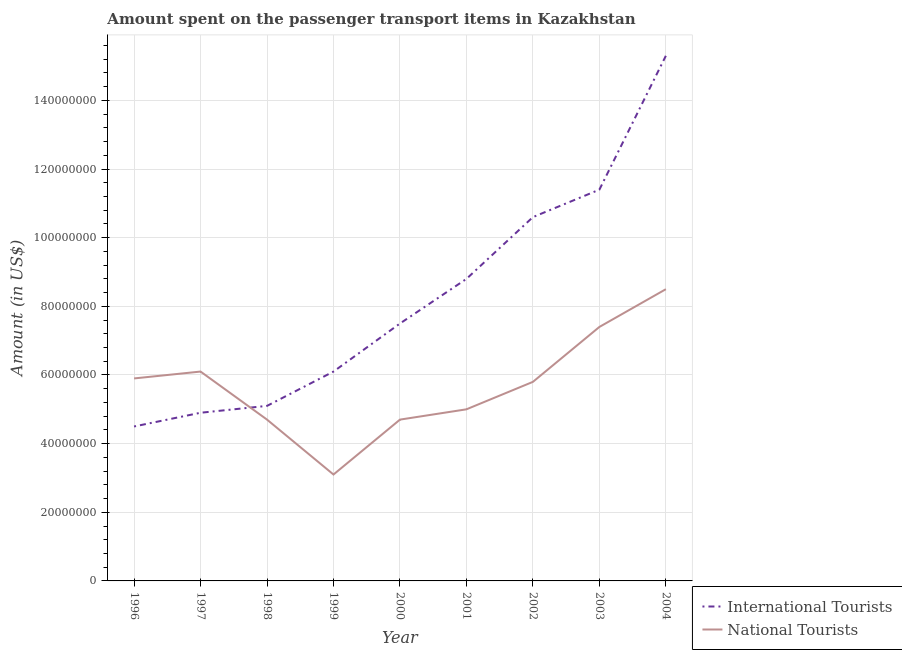Does the line corresponding to amount spent on transport items of international tourists intersect with the line corresponding to amount spent on transport items of national tourists?
Your answer should be compact. Yes. What is the amount spent on transport items of national tourists in 1998?
Keep it short and to the point. 4.70e+07. Across all years, what is the maximum amount spent on transport items of international tourists?
Ensure brevity in your answer.  1.53e+08. Across all years, what is the minimum amount spent on transport items of national tourists?
Ensure brevity in your answer.  3.10e+07. In which year was the amount spent on transport items of national tourists maximum?
Ensure brevity in your answer.  2004. In which year was the amount spent on transport items of national tourists minimum?
Provide a short and direct response. 1999. What is the total amount spent on transport items of international tourists in the graph?
Your answer should be compact. 7.42e+08. What is the difference between the amount spent on transport items of international tourists in 1999 and that in 2004?
Make the answer very short. -9.20e+07. What is the difference between the amount spent on transport items of national tourists in 2003 and the amount spent on transport items of international tourists in 1997?
Provide a short and direct response. 2.50e+07. What is the average amount spent on transport items of national tourists per year?
Make the answer very short. 5.69e+07. In the year 1999, what is the difference between the amount spent on transport items of international tourists and amount spent on transport items of national tourists?
Ensure brevity in your answer.  3.00e+07. In how many years, is the amount spent on transport items of international tourists greater than 144000000 US$?
Give a very brief answer. 1. What is the ratio of the amount spent on transport items of international tourists in 1997 to that in 1998?
Provide a short and direct response. 0.96. Is the amount spent on transport items of international tourists in 1998 less than that in 2003?
Make the answer very short. Yes. What is the difference between the highest and the second highest amount spent on transport items of international tourists?
Provide a short and direct response. 3.90e+07. What is the difference between the highest and the lowest amount spent on transport items of international tourists?
Give a very brief answer. 1.08e+08. In how many years, is the amount spent on transport items of national tourists greater than the average amount spent on transport items of national tourists taken over all years?
Provide a succinct answer. 5. Is the amount spent on transport items of national tourists strictly greater than the amount spent on transport items of international tourists over the years?
Provide a short and direct response. No. How many lines are there?
Ensure brevity in your answer.  2. How many years are there in the graph?
Give a very brief answer. 9. Does the graph contain any zero values?
Ensure brevity in your answer.  No. Does the graph contain grids?
Your answer should be very brief. Yes. How are the legend labels stacked?
Your answer should be compact. Vertical. What is the title of the graph?
Provide a short and direct response. Amount spent on the passenger transport items in Kazakhstan. Does "Investment" appear as one of the legend labels in the graph?
Offer a terse response. No. What is the label or title of the X-axis?
Give a very brief answer. Year. What is the Amount (in US$) of International Tourists in 1996?
Make the answer very short. 4.50e+07. What is the Amount (in US$) in National Tourists in 1996?
Keep it short and to the point. 5.90e+07. What is the Amount (in US$) of International Tourists in 1997?
Offer a very short reply. 4.90e+07. What is the Amount (in US$) in National Tourists in 1997?
Your answer should be compact. 6.10e+07. What is the Amount (in US$) in International Tourists in 1998?
Offer a very short reply. 5.10e+07. What is the Amount (in US$) in National Tourists in 1998?
Keep it short and to the point. 4.70e+07. What is the Amount (in US$) in International Tourists in 1999?
Your response must be concise. 6.10e+07. What is the Amount (in US$) in National Tourists in 1999?
Offer a very short reply. 3.10e+07. What is the Amount (in US$) in International Tourists in 2000?
Offer a terse response. 7.50e+07. What is the Amount (in US$) in National Tourists in 2000?
Provide a short and direct response. 4.70e+07. What is the Amount (in US$) in International Tourists in 2001?
Ensure brevity in your answer.  8.80e+07. What is the Amount (in US$) in National Tourists in 2001?
Keep it short and to the point. 5.00e+07. What is the Amount (in US$) of International Tourists in 2002?
Offer a terse response. 1.06e+08. What is the Amount (in US$) in National Tourists in 2002?
Offer a very short reply. 5.80e+07. What is the Amount (in US$) of International Tourists in 2003?
Give a very brief answer. 1.14e+08. What is the Amount (in US$) in National Tourists in 2003?
Offer a very short reply. 7.40e+07. What is the Amount (in US$) in International Tourists in 2004?
Give a very brief answer. 1.53e+08. What is the Amount (in US$) in National Tourists in 2004?
Provide a succinct answer. 8.50e+07. Across all years, what is the maximum Amount (in US$) in International Tourists?
Your answer should be compact. 1.53e+08. Across all years, what is the maximum Amount (in US$) in National Tourists?
Keep it short and to the point. 8.50e+07. Across all years, what is the minimum Amount (in US$) in International Tourists?
Offer a very short reply. 4.50e+07. Across all years, what is the minimum Amount (in US$) in National Tourists?
Your answer should be very brief. 3.10e+07. What is the total Amount (in US$) in International Tourists in the graph?
Your response must be concise. 7.42e+08. What is the total Amount (in US$) of National Tourists in the graph?
Offer a terse response. 5.12e+08. What is the difference between the Amount (in US$) of International Tourists in 1996 and that in 1998?
Provide a short and direct response. -6.00e+06. What is the difference between the Amount (in US$) of International Tourists in 1996 and that in 1999?
Your answer should be very brief. -1.60e+07. What is the difference between the Amount (in US$) in National Tourists in 1996 and that in 1999?
Make the answer very short. 2.80e+07. What is the difference between the Amount (in US$) in International Tourists in 1996 and that in 2000?
Give a very brief answer. -3.00e+07. What is the difference between the Amount (in US$) in National Tourists in 1996 and that in 2000?
Your answer should be very brief. 1.20e+07. What is the difference between the Amount (in US$) of International Tourists in 1996 and that in 2001?
Ensure brevity in your answer.  -4.30e+07. What is the difference between the Amount (in US$) of National Tourists in 1996 and that in 2001?
Provide a short and direct response. 9.00e+06. What is the difference between the Amount (in US$) of International Tourists in 1996 and that in 2002?
Offer a terse response. -6.10e+07. What is the difference between the Amount (in US$) in National Tourists in 1996 and that in 2002?
Your answer should be compact. 1.00e+06. What is the difference between the Amount (in US$) of International Tourists in 1996 and that in 2003?
Offer a terse response. -6.90e+07. What is the difference between the Amount (in US$) of National Tourists in 1996 and that in 2003?
Your answer should be very brief. -1.50e+07. What is the difference between the Amount (in US$) in International Tourists in 1996 and that in 2004?
Offer a terse response. -1.08e+08. What is the difference between the Amount (in US$) in National Tourists in 1996 and that in 2004?
Your answer should be compact. -2.60e+07. What is the difference between the Amount (in US$) in International Tourists in 1997 and that in 1998?
Your answer should be very brief. -2.00e+06. What is the difference between the Amount (in US$) in National Tourists in 1997 and that in 1998?
Offer a very short reply. 1.40e+07. What is the difference between the Amount (in US$) of International Tourists in 1997 and that in 1999?
Make the answer very short. -1.20e+07. What is the difference between the Amount (in US$) of National Tourists in 1997 and that in 1999?
Make the answer very short. 3.00e+07. What is the difference between the Amount (in US$) of International Tourists in 1997 and that in 2000?
Your answer should be compact. -2.60e+07. What is the difference between the Amount (in US$) in National Tourists in 1997 and that in 2000?
Offer a terse response. 1.40e+07. What is the difference between the Amount (in US$) of International Tourists in 1997 and that in 2001?
Your answer should be compact. -3.90e+07. What is the difference between the Amount (in US$) in National Tourists in 1997 and that in 2001?
Ensure brevity in your answer.  1.10e+07. What is the difference between the Amount (in US$) of International Tourists in 1997 and that in 2002?
Ensure brevity in your answer.  -5.70e+07. What is the difference between the Amount (in US$) in National Tourists in 1997 and that in 2002?
Your answer should be very brief. 3.00e+06. What is the difference between the Amount (in US$) of International Tourists in 1997 and that in 2003?
Offer a terse response. -6.50e+07. What is the difference between the Amount (in US$) in National Tourists in 1997 and that in 2003?
Give a very brief answer. -1.30e+07. What is the difference between the Amount (in US$) of International Tourists in 1997 and that in 2004?
Offer a terse response. -1.04e+08. What is the difference between the Amount (in US$) in National Tourists in 1997 and that in 2004?
Make the answer very short. -2.40e+07. What is the difference between the Amount (in US$) in International Tourists in 1998 and that in 1999?
Your answer should be compact. -1.00e+07. What is the difference between the Amount (in US$) in National Tourists in 1998 and that in 1999?
Provide a succinct answer. 1.60e+07. What is the difference between the Amount (in US$) in International Tourists in 1998 and that in 2000?
Your answer should be compact. -2.40e+07. What is the difference between the Amount (in US$) of International Tourists in 1998 and that in 2001?
Offer a very short reply. -3.70e+07. What is the difference between the Amount (in US$) in International Tourists in 1998 and that in 2002?
Keep it short and to the point. -5.50e+07. What is the difference between the Amount (in US$) in National Tourists in 1998 and that in 2002?
Ensure brevity in your answer.  -1.10e+07. What is the difference between the Amount (in US$) in International Tourists in 1998 and that in 2003?
Offer a terse response. -6.30e+07. What is the difference between the Amount (in US$) in National Tourists in 1998 and that in 2003?
Provide a succinct answer. -2.70e+07. What is the difference between the Amount (in US$) of International Tourists in 1998 and that in 2004?
Offer a terse response. -1.02e+08. What is the difference between the Amount (in US$) in National Tourists in 1998 and that in 2004?
Provide a short and direct response. -3.80e+07. What is the difference between the Amount (in US$) of International Tourists in 1999 and that in 2000?
Give a very brief answer. -1.40e+07. What is the difference between the Amount (in US$) in National Tourists in 1999 and that in 2000?
Keep it short and to the point. -1.60e+07. What is the difference between the Amount (in US$) in International Tourists in 1999 and that in 2001?
Offer a very short reply. -2.70e+07. What is the difference between the Amount (in US$) in National Tourists in 1999 and that in 2001?
Give a very brief answer. -1.90e+07. What is the difference between the Amount (in US$) of International Tourists in 1999 and that in 2002?
Your response must be concise. -4.50e+07. What is the difference between the Amount (in US$) of National Tourists in 1999 and that in 2002?
Your response must be concise. -2.70e+07. What is the difference between the Amount (in US$) of International Tourists in 1999 and that in 2003?
Ensure brevity in your answer.  -5.30e+07. What is the difference between the Amount (in US$) in National Tourists in 1999 and that in 2003?
Ensure brevity in your answer.  -4.30e+07. What is the difference between the Amount (in US$) in International Tourists in 1999 and that in 2004?
Give a very brief answer. -9.20e+07. What is the difference between the Amount (in US$) of National Tourists in 1999 and that in 2004?
Offer a very short reply. -5.40e+07. What is the difference between the Amount (in US$) of International Tourists in 2000 and that in 2001?
Your response must be concise. -1.30e+07. What is the difference between the Amount (in US$) in National Tourists in 2000 and that in 2001?
Your response must be concise. -3.00e+06. What is the difference between the Amount (in US$) of International Tourists in 2000 and that in 2002?
Provide a short and direct response. -3.10e+07. What is the difference between the Amount (in US$) in National Tourists in 2000 and that in 2002?
Your answer should be very brief. -1.10e+07. What is the difference between the Amount (in US$) in International Tourists in 2000 and that in 2003?
Offer a very short reply. -3.90e+07. What is the difference between the Amount (in US$) in National Tourists in 2000 and that in 2003?
Provide a succinct answer. -2.70e+07. What is the difference between the Amount (in US$) of International Tourists in 2000 and that in 2004?
Give a very brief answer. -7.80e+07. What is the difference between the Amount (in US$) in National Tourists in 2000 and that in 2004?
Ensure brevity in your answer.  -3.80e+07. What is the difference between the Amount (in US$) in International Tourists in 2001 and that in 2002?
Your answer should be very brief. -1.80e+07. What is the difference between the Amount (in US$) in National Tourists in 2001 and that in 2002?
Your answer should be very brief. -8.00e+06. What is the difference between the Amount (in US$) in International Tourists in 2001 and that in 2003?
Offer a very short reply. -2.60e+07. What is the difference between the Amount (in US$) of National Tourists in 2001 and that in 2003?
Offer a terse response. -2.40e+07. What is the difference between the Amount (in US$) of International Tourists in 2001 and that in 2004?
Ensure brevity in your answer.  -6.50e+07. What is the difference between the Amount (in US$) in National Tourists in 2001 and that in 2004?
Give a very brief answer. -3.50e+07. What is the difference between the Amount (in US$) of International Tourists in 2002 and that in 2003?
Make the answer very short. -8.00e+06. What is the difference between the Amount (in US$) of National Tourists in 2002 and that in 2003?
Keep it short and to the point. -1.60e+07. What is the difference between the Amount (in US$) in International Tourists in 2002 and that in 2004?
Your response must be concise. -4.70e+07. What is the difference between the Amount (in US$) in National Tourists in 2002 and that in 2004?
Your answer should be compact. -2.70e+07. What is the difference between the Amount (in US$) of International Tourists in 2003 and that in 2004?
Keep it short and to the point. -3.90e+07. What is the difference between the Amount (in US$) in National Tourists in 2003 and that in 2004?
Provide a succinct answer. -1.10e+07. What is the difference between the Amount (in US$) of International Tourists in 1996 and the Amount (in US$) of National Tourists in 1997?
Provide a short and direct response. -1.60e+07. What is the difference between the Amount (in US$) of International Tourists in 1996 and the Amount (in US$) of National Tourists in 1998?
Keep it short and to the point. -2.00e+06. What is the difference between the Amount (in US$) in International Tourists in 1996 and the Amount (in US$) in National Tourists in 1999?
Keep it short and to the point. 1.40e+07. What is the difference between the Amount (in US$) in International Tourists in 1996 and the Amount (in US$) in National Tourists in 2000?
Make the answer very short. -2.00e+06. What is the difference between the Amount (in US$) of International Tourists in 1996 and the Amount (in US$) of National Tourists in 2001?
Provide a short and direct response. -5.00e+06. What is the difference between the Amount (in US$) in International Tourists in 1996 and the Amount (in US$) in National Tourists in 2002?
Give a very brief answer. -1.30e+07. What is the difference between the Amount (in US$) in International Tourists in 1996 and the Amount (in US$) in National Tourists in 2003?
Make the answer very short. -2.90e+07. What is the difference between the Amount (in US$) in International Tourists in 1996 and the Amount (in US$) in National Tourists in 2004?
Your answer should be compact. -4.00e+07. What is the difference between the Amount (in US$) in International Tourists in 1997 and the Amount (in US$) in National Tourists in 1998?
Give a very brief answer. 2.00e+06. What is the difference between the Amount (in US$) in International Tourists in 1997 and the Amount (in US$) in National Tourists in 1999?
Provide a short and direct response. 1.80e+07. What is the difference between the Amount (in US$) in International Tourists in 1997 and the Amount (in US$) in National Tourists in 2002?
Ensure brevity in your answer.  -9.00e+06. What is the difference between the Amount (in US$) of International Tourists in 1997 and the Amount (in US$) of National Tourists in 2003?
Ensure brevity in your answer.  -2.50e+07. What is the difference between the Amount (in US$) in International Tourists in 1997 and the Amount (in US$) in National Tourists in 2004?
Offer a very short reply. -3.60e+07. What is the difference between the Amount (in US$) of International Tourists in 1998 and the Amount (in US$) of National Tourists in 2001?
Keep it short and to the point. 1.00e+06. What is the difference between the Amount (in US$) in International Tourists in 1998 and the Amount (in US$) in National Tourists in 2002?
Keep it short and to the point. -7.00e+06. What is the difference between the Amount (in US$) in International Tourists in 1998 and the Amount (in US$) in National Tourists in 2003?
Provide a succinct answer. -2.30e+07. What is the difference between the Amount (in US$) in International Tourists in 1998 and the Amount (in US$) in National Tourists in 2004?
Your answer should be compact. -3.40e+07. What is the difference between the Amount (in US$) in International Tourists in 1999 and the Amount (in US$) in National Tourists in 2000?
Offer a terse response. 1.40e+07. What is the difference between the Amount (in US$) of International Tourists in 1999 and the Amount (in US$) of National Tourists in 2001?
Offer a terse response. 1.10e+07. What is the difference between the Amount (in US$) in International Tourists in 1999 and the Amount (in US$) in National Tourists in 2003?
Provide a short and direct response. -1.30e+07. What is the difference between the Amount (in US$) of International Tourists in 1999 and the Amount (in US$) of National Tourists in 2004?
Offer a very short reply. -2.40e+07. What is the difference between the Amount (in US$) of International Tourists in 2000 and the Amount (in US$) of National Tourists in 2001?
Your response must be concise. 2.50e+07. What is the difference between the Amount (in US$) of International Tourists in 2000 and the Amount (in US$) of National Tourists in 2002?
Offer a very short reply. 1.70e+07. What is the difference between the Amount (in US$) in International Tourists in 2000 and the Amount (in US$) in National Tourists in 2003?
Offer a terse response. 1.00e+06. What is the difference between the Amount (in US$) of International Tourists in 2000 and the Amount (in US$) of National Tourists in 2004?
Give a very brief answer. -1.00e+07. What is the difference between the Amount (in US$) in International Tourists in 2001 and the Amount (in US$) in National Tourists in 2002?
Keep it short and to the point. 3.00e+07. What is the difference between the Amount (in US$) in International Tourists in 2001 and the Amount (in US$) in National Tourists in 2003?
Provide a succinct answer. 1.40e+07. What is the difference between the Amount (in US$) of International Tourists in 2002 and the Amount (in US$) of National Tourists in 2003?
Offer a terse response. 3.20e+07. What is the difference between the Amount (in US$) in International Tourists in 2002 and the Amount (in US$) in National Tourists in 2004?
Offer a very short reply. 2.10e+07. What is the difference between the Amount (in US$) in International Tourists in 2003 and the Amount (in US$) in National Tourists in 2004?
Give a very brief answer. 2.90e+07. What is the average Amount (in US$) in International Tourists per year?
Offer a very short reply. 8.24e+07. What is the average Amount (in US$) of National Tourists per year?
Provide a short and direct response. 5.69e+07. In the year 1996, what is the difference between the Amount (in US$) of International Tourists and Amount (in US$) of National Tourists?
Give a very brief answer. -1.40e+07. In the year 1997, what is the difference between the Amount (in US$) in International Tourists and Amount (in US$) in National Tourists?
Your answer should be very brief. -1.20e+07. In the year 1999, what is the difference between the Amount (in US$) of International Tourists and Amount (in US$) of National Tourists?
Offer a very short reply. 3.00e+07. In the year 2000, what is the difference between the Amount (in US$) in International Tourists and Amount (in US$) in National Tourists?
Offer a terse response. 2.80e+07. In the year 2001, what is the difference between the Amount (in US$) of International Tourists and Amount (in US$) of National Tourists?
Offer a very short reply. 3.80e+07. In the year 2002, what is the difference between the Amount (in US$) of International Tourists and Amount (in US$) of National Tourists?
Your answer should be very brief. 4.80e+07. In the year 2003, what is the difference between the Amount (in US$) of International Tourists and Amount (in US$) of National Tourists?
Offer a very short reply. 4.00e+07. In the year 2004, what is the difference between the Amount (in US$) in International Tourists and Amount (in US$) in National Tourists?
Keep it short and to the point. 6.80e+07. What is the ratio of the Amount (in US$) in International Tourists in 1996 to that in 1997?
Your answer should be very brief. 0.92. What is the ratio of the Amount (in US$) in National Tourists in 1996 to that in 1997?
Make the answer very short. 0.97. What is the ratio of the Amount (in US$) in International Tourists in 1996 to that in 1998?
Provide a succinct answer. 0.88. What is the ratio of the Amount (in US$) in National Tourists in 1996 to that in 1998?
Provide a short and direct response. 1.26. What is the ratio of the Amount (in US$) in International Tourists in 1996 to that in 1999?
Provide a succinct answer. 0.74. What is the ratio of the Amount (in US$) of National Tourists in 1996 to that in 1999?
Give a very brief answer. 1.9. What is the ratio of the Amount (in US$) of National Tourists in 1996 to that in 2000?
Offer a terse response. 1.26. What is the ratio of the Amount (in US$) in International Tourists in 1996 to that in 2001?
Make the answer very short. 0.51. What is the ratio of the Amount (in US$) in National Tourists in 1996 to that in 2001?
Provide a succinct answer. 1.18. What is the ratio of the Amount (in US$) in International Tourists in 1996 to that in 2002?
Make the answer very short. 0.42. What is the ratio of the Amount (in US$) of National Tourists in 1996 to that in 2002?
Offer a very short reply. 1.02. What is the ratio of the Amount (in US$) in International Tourists in 1996 to that in 2003?
Your answer should be compact. 0.39. What is the ratio of the Amount (in US$) in National Tourists in 1996 to that in 2003?
Provide a short and direct response. 0.8. What is the ratio of the Amount (in US$) of International Tourists in 1996 to that in 2004?
Give a very brief answer. 0.29. What is the ratio of the Amount (in US$) in National Tourists in 1996 to that in 2004?
Your answer should be compact. 0.69. What is the ratio of the Amount (in US$) of International Tourists in 1997 to that in 1998?
Your response must be concise. 0.96. What is the ratio of the Amount (in US$) of National Tourists in 1997 to that in 1998?
Provide a short and direct response. 1.3. What is the ratio of the Amount (in US$) of International Tourists in 1997 to that in 1999?
Your response must be concise. 0.8. What is the ratio of the Amount (in US$) of National Tourists in 1997 to that in 1999?
Ensure brevity in your answer.  1.97. What is the ratio of the Amount (in US$) of International Tourists in 1997 to that in 2000?
Your response must be concise. 0.65. What is the ratio of the Amount (in US$) of National Tourists in 1997 to that in 2000?
Keep it short and to the point. 1.3. What is the ratio of the Amount (in US$) of International Tourists in 1997 to that in 2001?
Provide a succinct answer. 0.56. What is the ratio of the Amount (in US$) in National Tourists in 1997 to that in 2001?
Your response must be concise. 1.22. What is the ratio of the Amount (in US$) of International Tourists in 1997 to that in 2002?
Offer a terse response. 0.46. What is the ratio of the Amount (in US$) in National Tourists in 1997 to that in 2002?
Offer a very short reply. 1.05. What is the ratio of the Amount (in US$) in International Tourists in 1997 to that in 2003?
Your response must be concise. 0.43. What is the ratio of the Amount (in US$) in National Tourists in 1997 to that in 2003?
Provide a short and direct response. 0.82. What is the ratio of the Amount (in US$) in International Tourists in 1997 to that in 2004?
Provide a short and direct response. 0.32. What is the ratio of the Amount (in US$) in National Tourists in 1997 to that in 2004?
Ensure brevity in your answer.  0.72. What is the ratio of the Amount (in US$) in International Tourists in 1998 to that in 1999?
Make the answer very short. 0.84. What is the ratio of the Amount (in US$) in National Tourists in 1998 to that in 1999?
Keep it short and to the point. 1.52. What is the ratio of the Amount (in US$) in International Tourists in 1998 to that in 2000?
Provide a succinct answer. 0.68. What is the ratio of the Amount (in US$) of International Tourists in 1998 to that in 2001?
Ensure brevity in your answer.  0.58. What is the ratio of the Amount (in US$) of International Tourists in 1998 to that in 2002?
Give a very brief answer. 0.48. What is the ratio of the Amount (in US$) of National Tourists in 1998 to that in 2002?
Keep it short and to the point. 0.81. What is the ratio of the Amount (in US$) of International Tourists in 1998 to that in 2003?
Provide a short and direct response. 0.45. What is the ratio of the Amount (in US$) in National Tourists in 1998 to that in 2003?
Your response must be concise. 0.64. What is the ratio of the Amount (in US$) in National Tourists in 1998 to that in 2004?
Ensure brevity in your answer.  0.55. What is the ratio of the Amount (in US$) in International Tourists in 1999 to that in 2000?
Your response must be concise. 0.81. What is the ratio of the Amount (in US$) in National Tourists in 1999 to that in 2000?
Offer a very short reply. 0.66. What is the ratio of the Amount (in US$) of International Tourists in 1999 to that in 2001?
Your response must be concise. 0.69. What is the ratio of the Amount (in US$) in National Tourists in 1999 to that in 2001?
Give a very brief answer. 0.62. What is the ratio of the Amount (in US$) in International Tourists in 1999 to that in 2002?
Offer a terse response. 0.58. What is the ratio of the Amount (in US$) of National Tourists in 1999 to that in 2002?
Offer a terse response. 0.53. What is the ratio of the Amount (in US$) of International Tourists in 1999 to that in 2003?
Give a very brief answer. 0.54. What is the ratio of the Amount (in US$) in National Tourists in 1999 to that in 2003?
Your answer should be very brief. 0.42. What is the ratio of the Amount (in US$) of International Tourists in 1999 to that in 2004?
Keep it short and to the point. 0.4. What is the ratio of the Amount (in US$) of National Tourists in 1999 to that in 2004?
Your response must be concise. 0.36. What is the ratio of the Amount (in US$) of International Tourists in 2000 to that in 2001?
Your response must be concise. 0.85. What is the ratio of the Amount (in US$) of International Tourists in 2000 to that in 2002?
Keep it short and to the point. 0.71. What is the ratio of the Amount (in US$) of National Tourists in 2000 to that in 2002?
Your answer should be very brief. 0.81. What is the ratio of the Amount (in US$) in International Tourists in 2000 to that in 2003?
Provide a succinct answer. 0.66. What is the ratio of the Amount (in US$) in National Tourists in 2000 to that in 2003?
Ensure brevity in your answer.  0.64. What is the ratio of the Amount (in US$) of International Tourists in 2000 to that in 2004?
Provide a short and direct response. 0.49. What is the ratio of the Amount (in US$) in National Tourists in 2000 to that in 2004?
Your answer should be compact. 0.55. What is the ratio of the Amount (in US$) in International Tourists in 2001 to that in 2002?
Provide a succinct answer. 0.83. What is the ratio of the Amount (in US$) in National Tourists in 2001 to that in 2002?
Offer a very short reply. 0.86. What is the ratio of the Amount (in US$) in International Tourists in 2001 to that in 2003?
Keep it short and to the point. 0.77. What is the ratio of the Amount (in US$) in National Tourists in 2001 to that in 2003?
Offer a very short reply. 0.68. What is the ratio of the Amount (in US$) of International Tourists in 2001 to that in 2004?
Your answer should be very brief. 0.58. What is the ratio of the Amount (in US$) of National Tourists in 2001 to that in 2004?
Keep it short and to the point. 0.59. What is the ratio of the Amount (in US$) of International Tourists in 2002 to that in 2003?
Your response must be concise. 0.93. What is the ratio of the Amount (in US$) in National Tourists in 2002 to that in 2003?
Offer a very short reply. 0.78. What is the ratio of the Amount (in US$) of International Tourists in 2002 to that in 2004?
Offer a terse response. 0.69. What is the ratio of the Amount (in US$) of National Tourists in 2002 to that in 2004?
Your answer should be compact. 0.68. What is the ratio of the Amount (in US$) of International Tourists in 2003 to that in 2004?
Your answer should be very brief. 0.75. What is the ratio of the Amount (in US$) of National Tourists in 2003 to that in 2004?
Ensure brevity in your answer.  0.87. What is the difference between the highest and the second highest Amount (in US$) of International Tourists?
Offer a terse response. 3.90e+07. What is the difference between the highest and the second highest Amount (in US$) of National Tourists?
Offer a terse response. 1.10e+07. What is the difference between the highest and the lowest Amount (in US$) in International Tourists?
Make the answer very short. 1.08e+08. What is the difference between the highest and the lowest Amount (in US$) in National Tourists?
Your answer should be compact. 5.40e+07. 